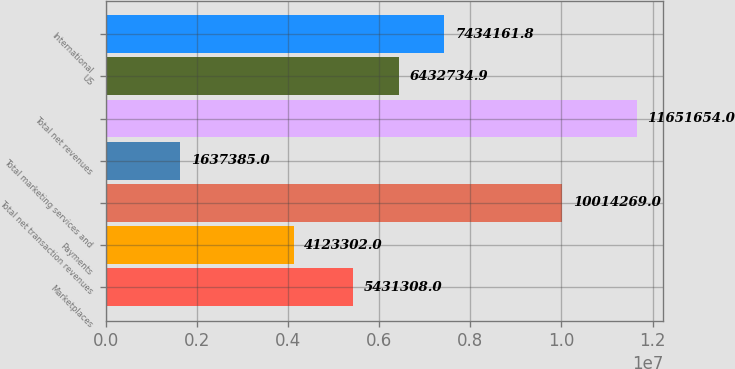<chart> <loc_0><loc_0><loc_500><loc_500><bar_chart><fcel>Marketplaces<fcel>Payments<fcel>Total net transaction revenues<fcel>Total marketing services and<fcel>Total net revenues<fcel>US<fcel>International<nl><fcel>5.43131e+06<fcel>4.1233e+06<fcel>1.00143e+07<fcel>1.63738e+06<fcel>1.16517e+07<fcel>6.43273e+06<fcel>7.43416e+06<nl></chart> 